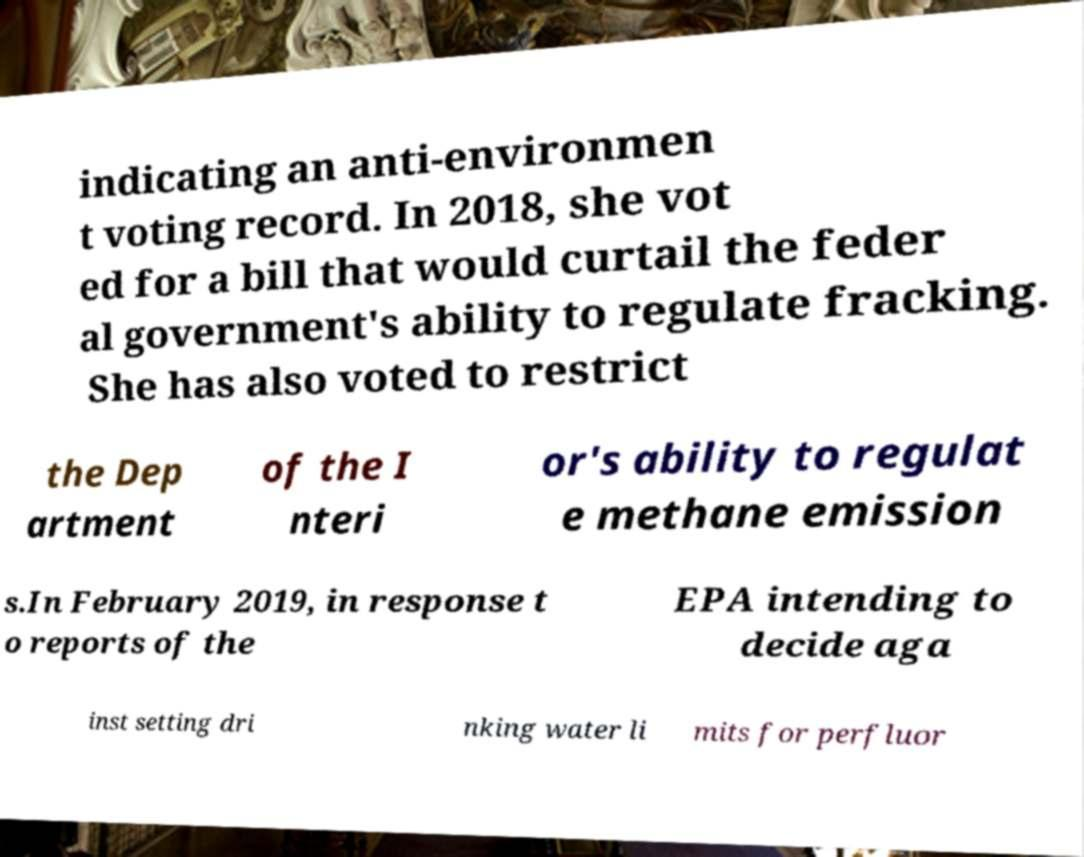I need the written content from this picture converted into text. Can you do that? indicating an anti-environmen t voting record. In 2018, she vot ed for a bill that would curtail the feder al government's ability to regulate fracking. She has also voted to restrict the Dep artment of the I nteri or's ability to regulat e methane emission s.In February 2019, in response t o reports of the EPA intending to decide aga inst setting dri nking water li mits for perfluor 